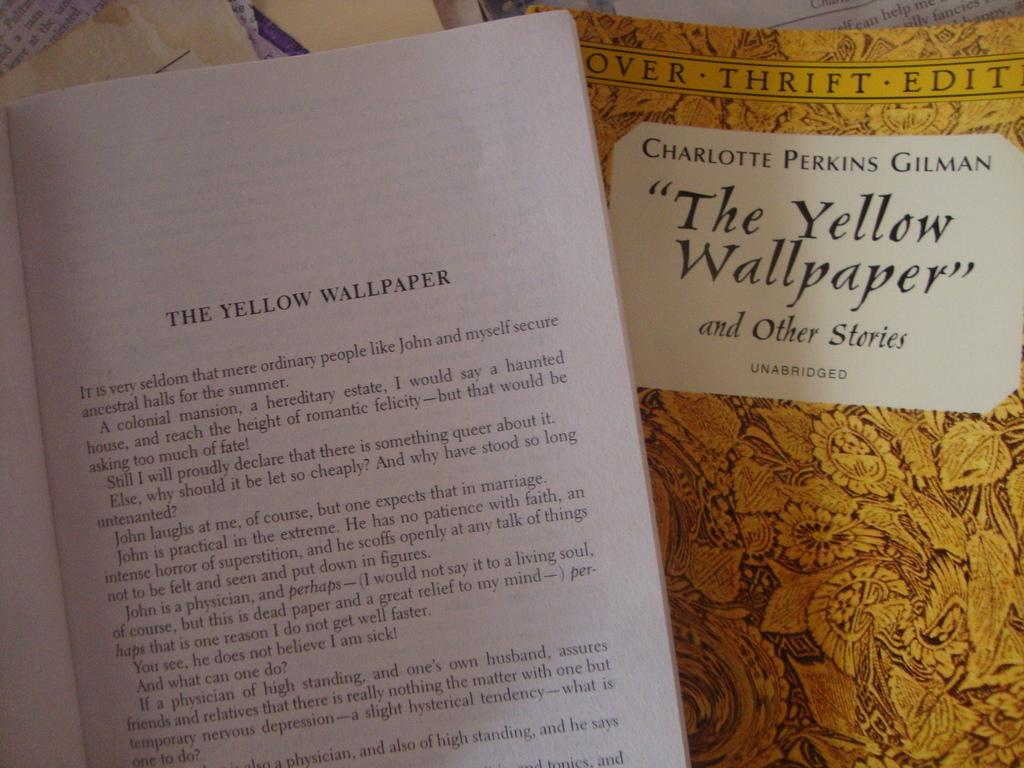<image>
Offer a succinct explanation of the picture presented. A book showing the cover and inside of a page called The Yellow Wallpaper. 